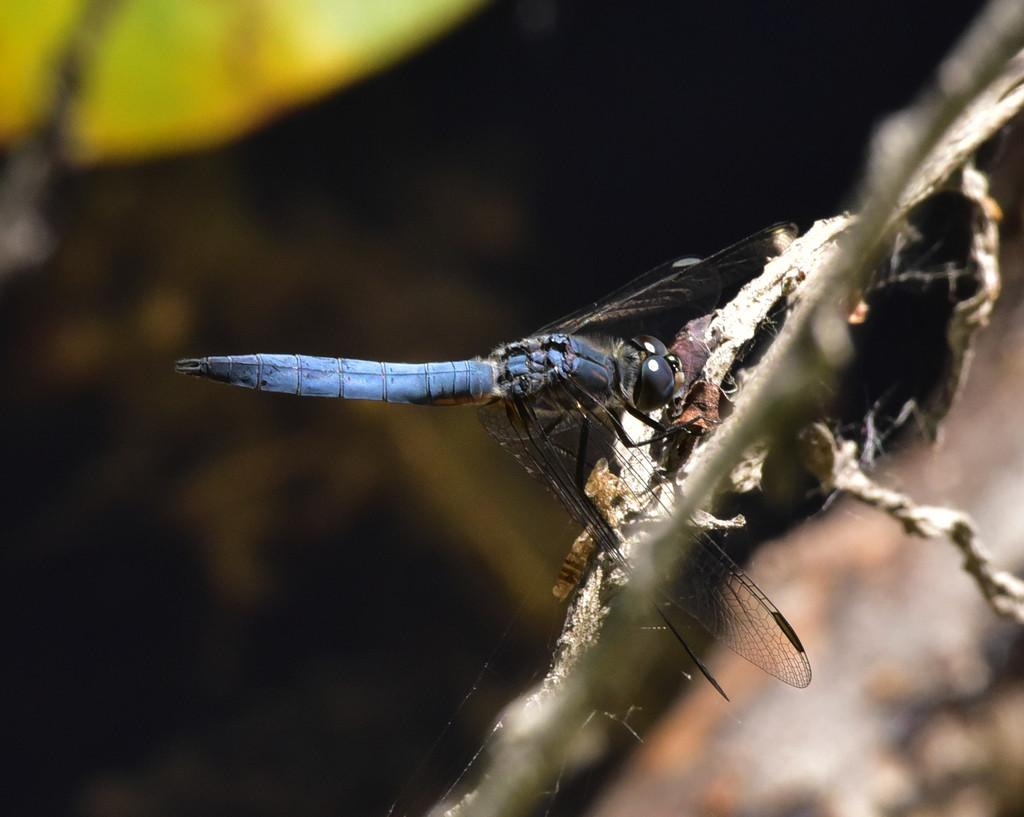What is the main subject of the image? There is a dragonfly in the image. Where is the dragonfly located? The dragonfly is on a plant. How would you describe the quality of the image? The image is blurry at the back. What colors can be seen on the dragonfly? The dragonfly has blue and black colors. What type of seed is the dragonfly planting in the image? There is no seed present in the image, nor is the dragonfly shown planting anything. 